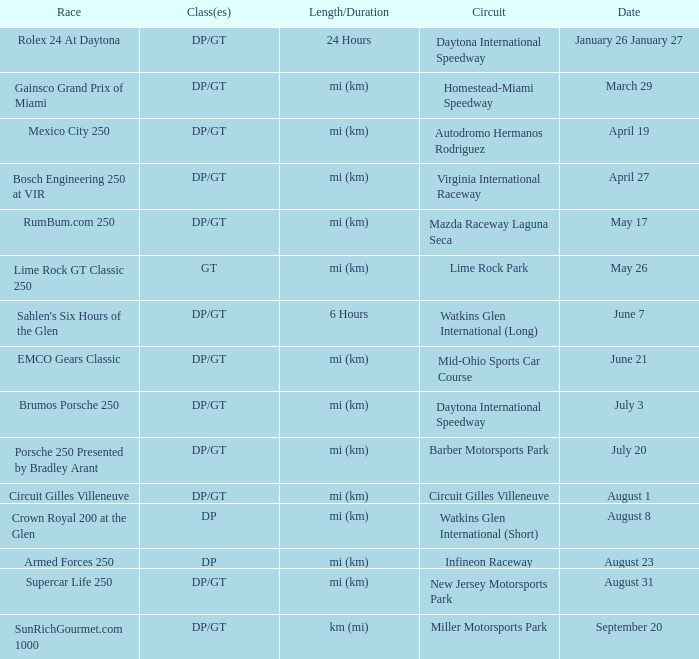What was the date of the race that lasted 6 hours? June 7. 